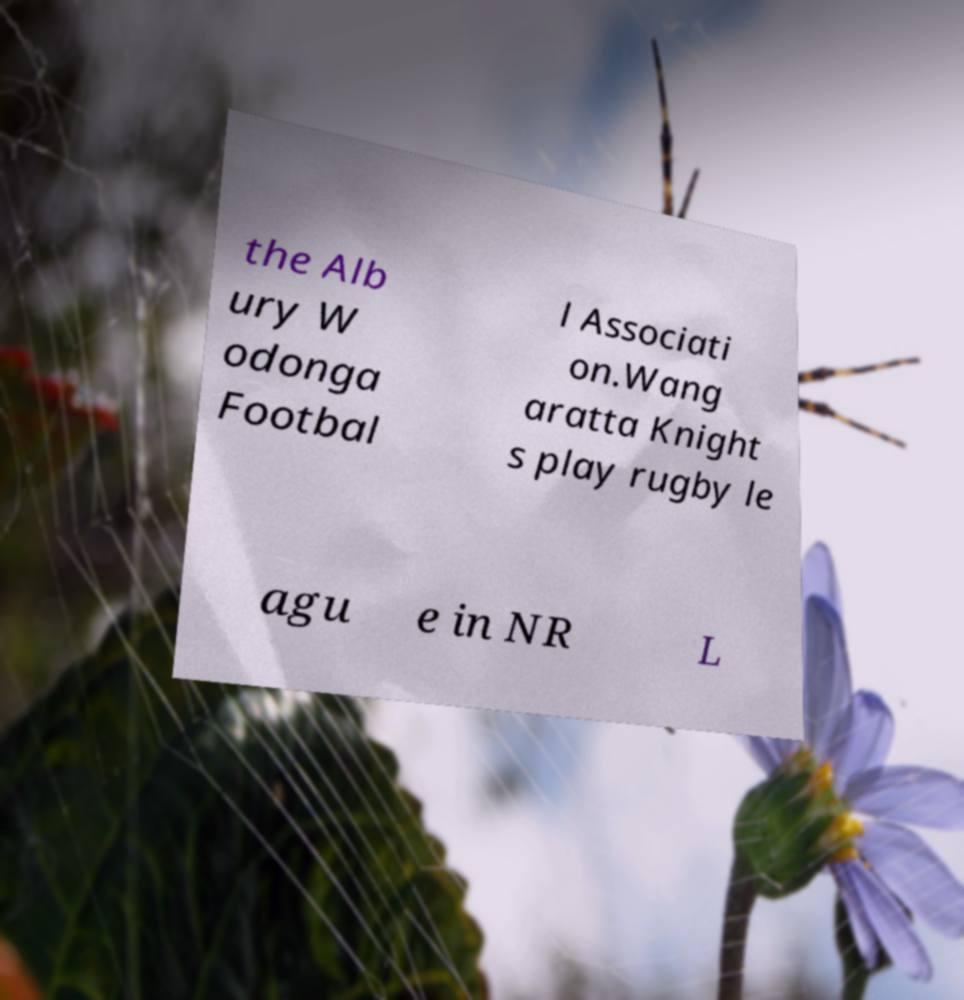Can you accurately transcribe the text from the provided image for me? the Alb ury W odonga Footbal l Associati on.Wang aratta Knight s play rugby le agu e in NR L 